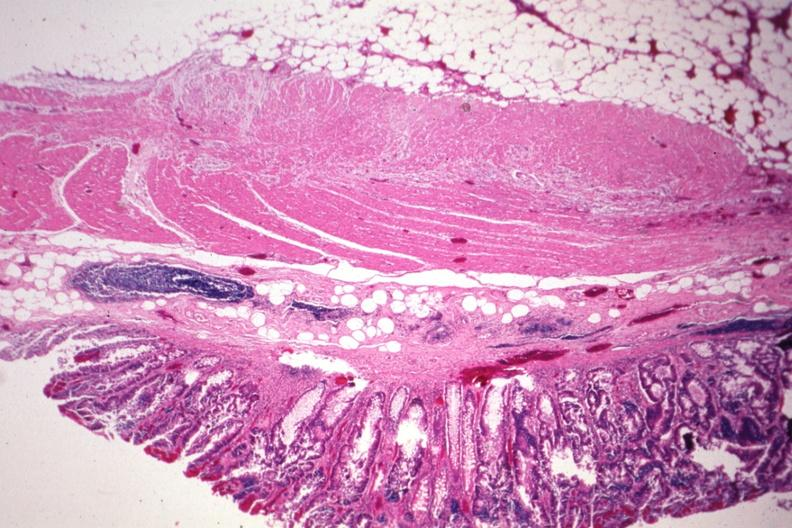s this typical thecoma with yellow foci present?
Answer the question using a single word or phrase. No 